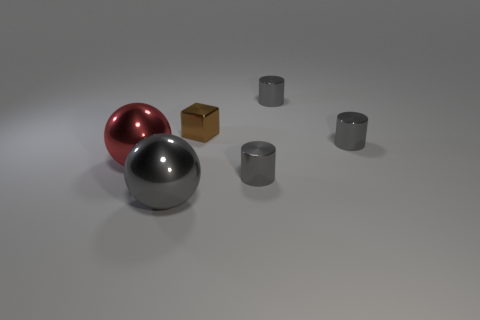Subtract all cubes. How many objects are left? 5 Subtract 1 cubes. How many cubes are left? 0 Subtract all yellow cubes. Subtract all blue balls. How many cubes are left? 1 Subtract all cyan cubes. How many yellow balls are left? 0 Subtract all red metallic objects. Subtract all tiny red matte spheres. How many objects are left? 5 Add 6 red things. How many red things are left? 7 Add 5 large red balls. How many large red balls exist? 6 Add 2 metal objects. How many objects exist? 8 Subtract all red balls. How many balls are left? 1 Subtract 1 brown cubes. How many objects are left? 5 